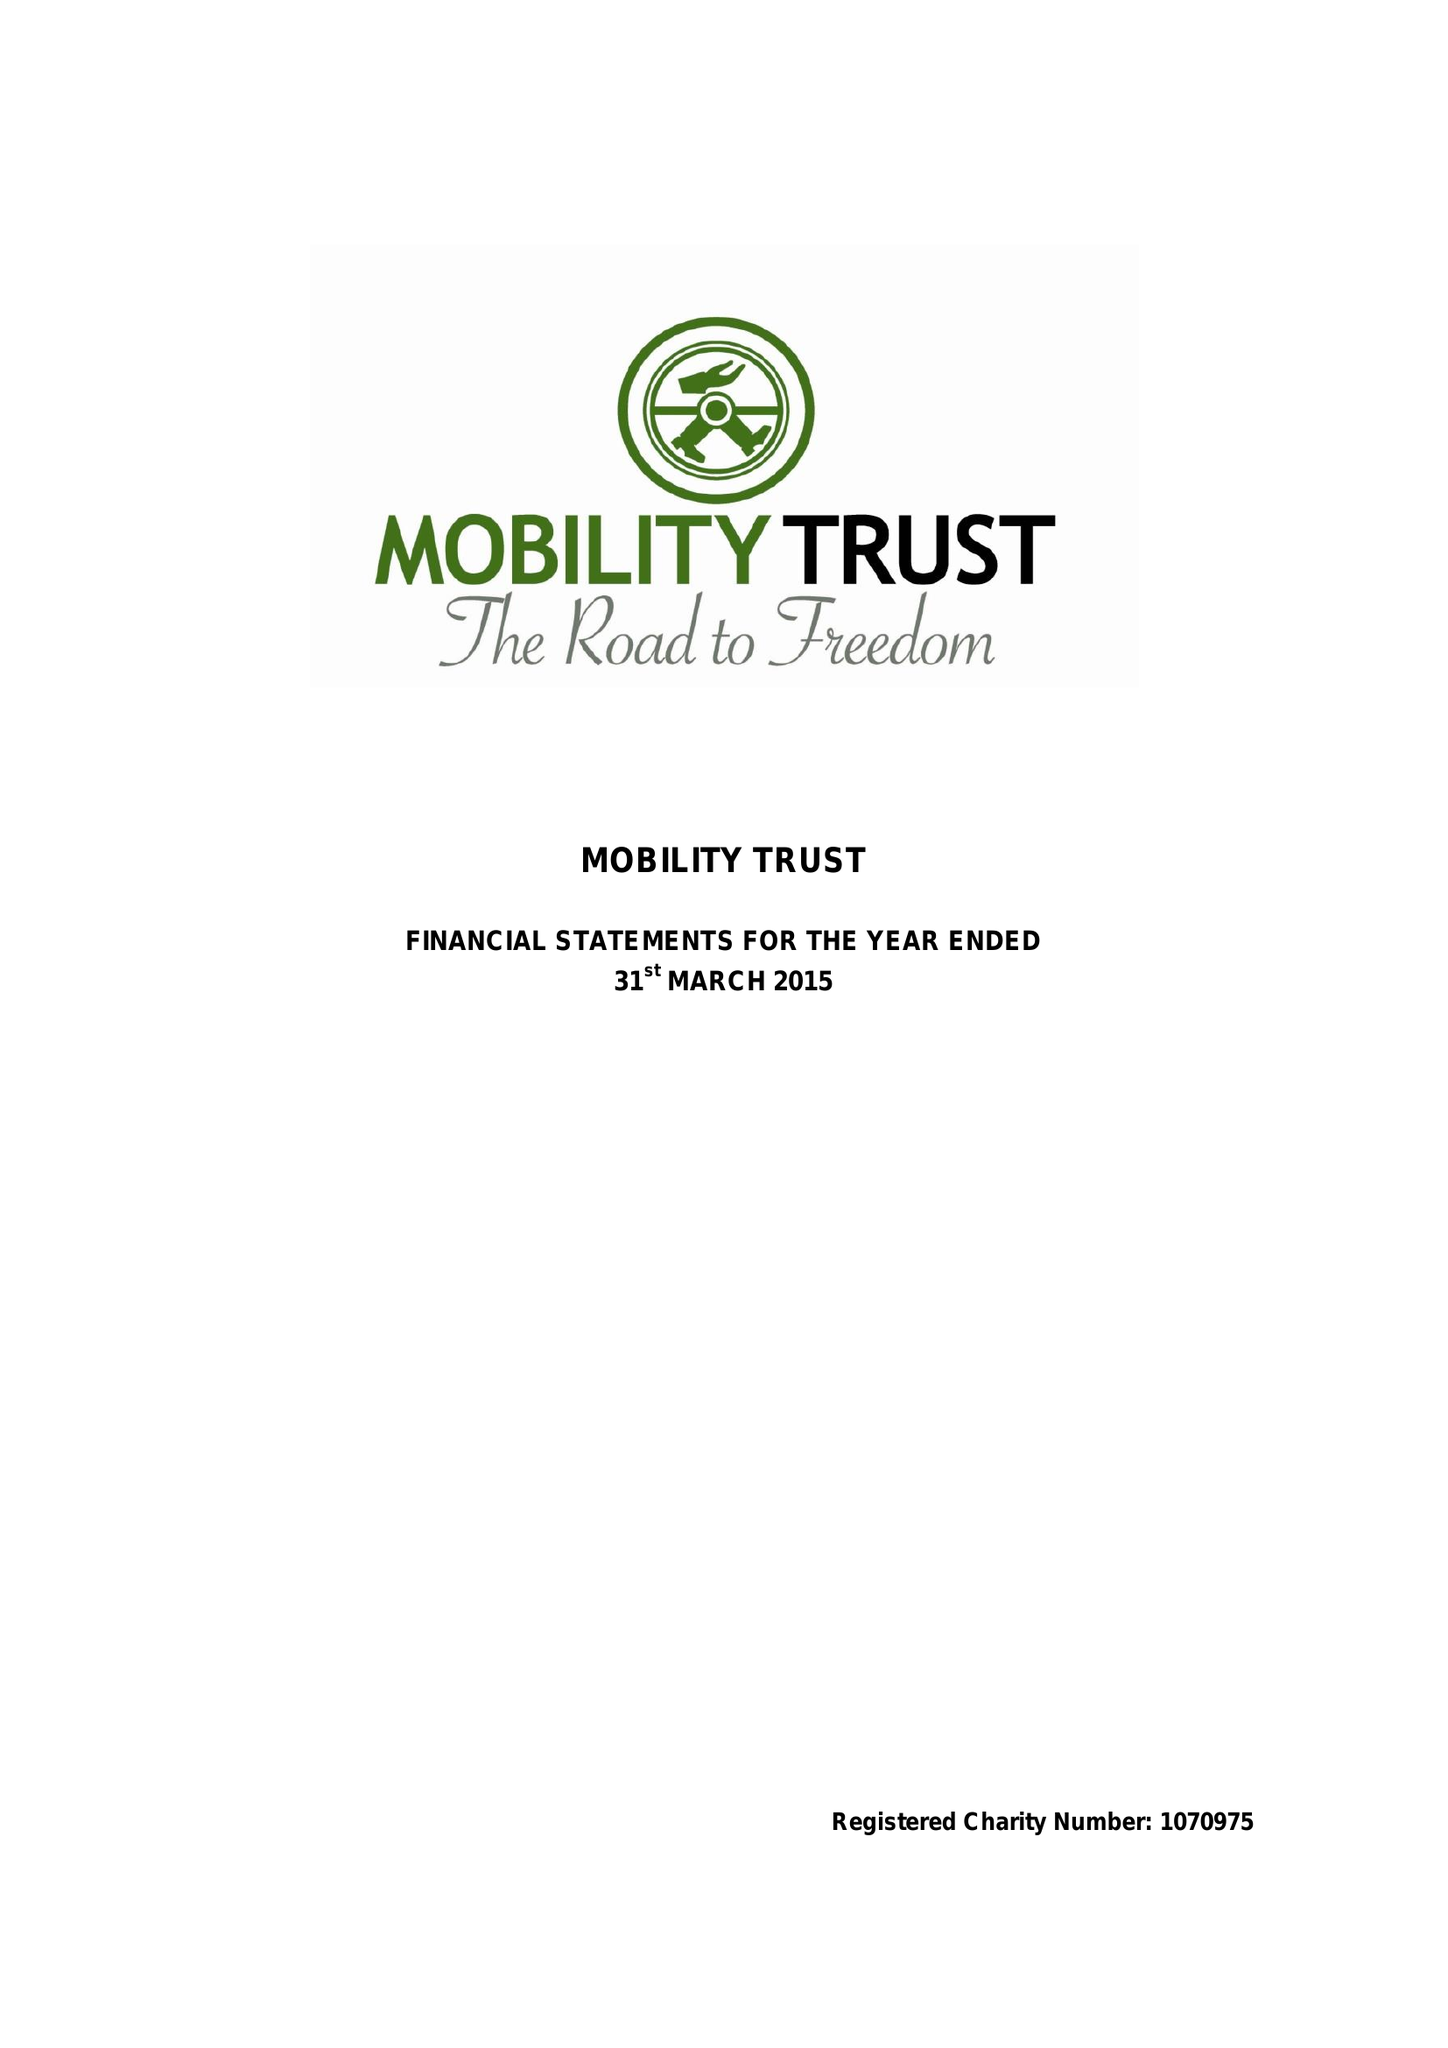What is the value for the address__post_town?
Answer the question using a single word or phrase. READING 